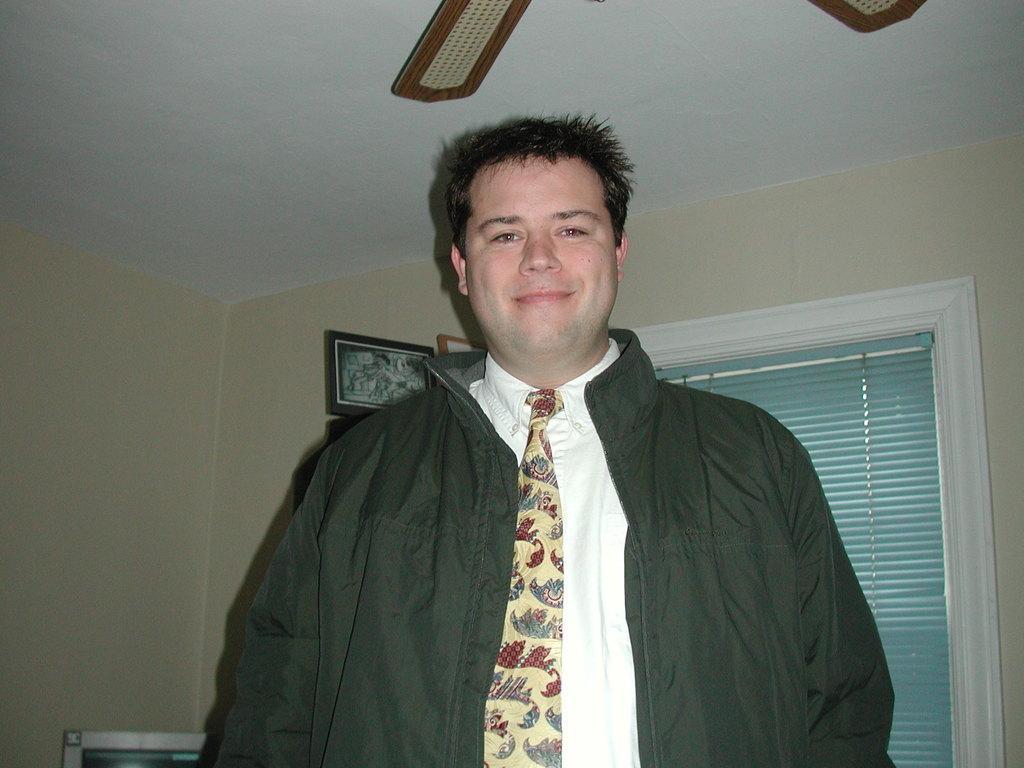Describe this image in one or two sentences. In this picture we can see a man wore a jacket, tie and smiling and at the back of him we can see frames on the wall, curtain, ceiling and some objects. 